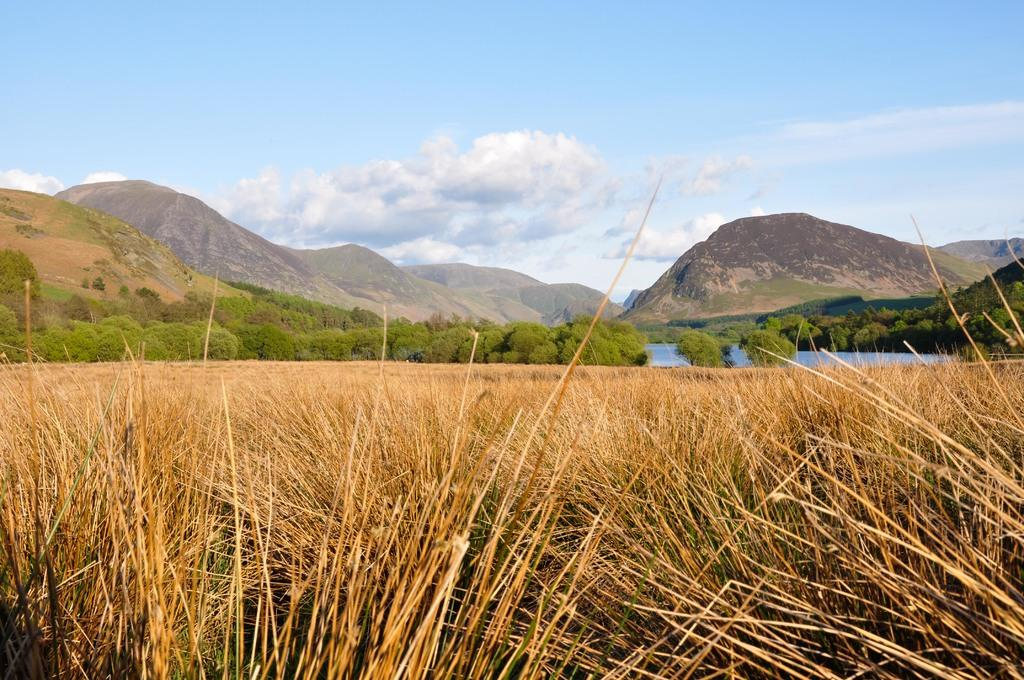What type of vegetation is present in the image? There is dry grass in the image. What other natural elements can be seen in the image? There are trees and water visible in the image. What is the terrain like in the image? There are hills in the image. What is visible in the background of the image? The sky is visible in the background of the image. What is the weather like in the image? The presence of clouds in the sky suggests that it might be partly cloudy. Where is the hydrant located in the image? There is no hydrant present in the image. What type of structure is visible in the image? There is no structure visible in the image; it features natural elements such as dry grass, trees, water, hills, and the sky. 